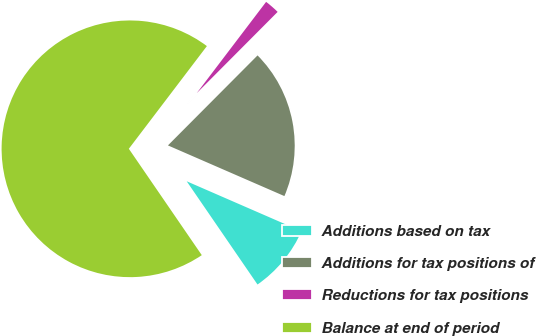<chart> <loc_0><loc_0><loc_500><loc_500><pie_chart><fcel>Additions based on tax<fcel>Additions for tax positions of<fcel>Reductions for tax positions<fcel>Balance at end of period<nl><fcel>8.9%<fcel>19.07%<fcel>2.12%<fcel>69.92%<nl></chart> 